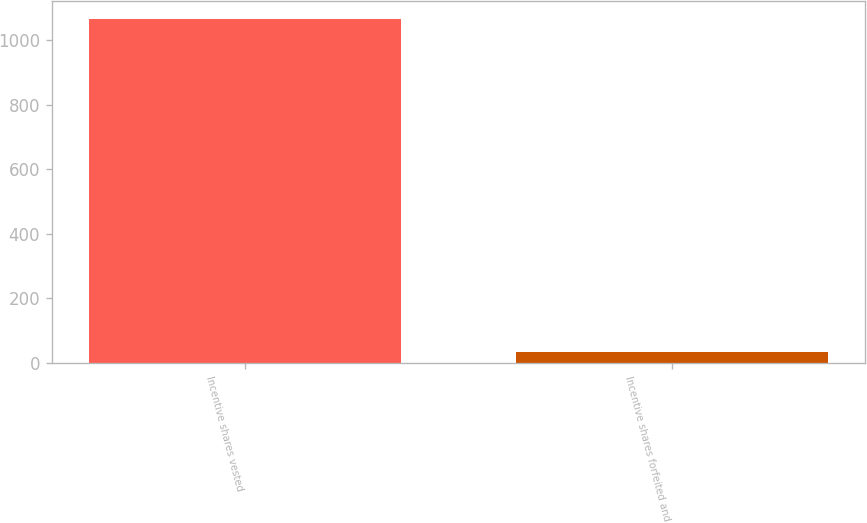Convert chart. <chart><loc_0><loc_0><loc_500><loc_500><bar_chart><fcel>Incentive shares vested<fcel>Incentive shares forfeited and<nl><fcel>1066<fcel>32<nl></chart> 